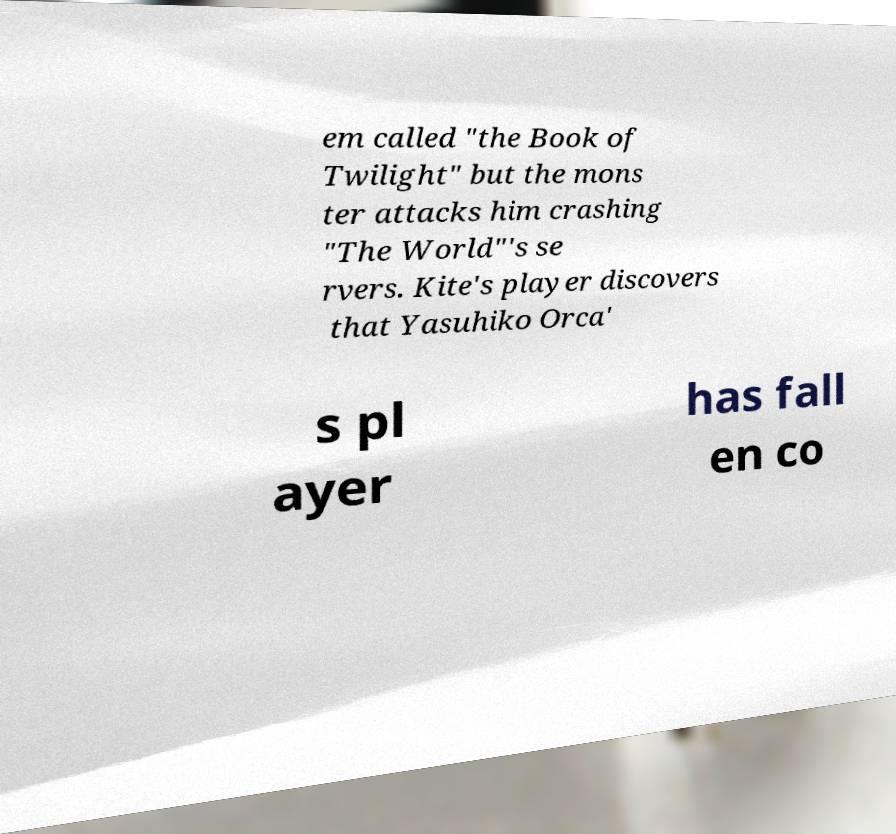Please identify and transcribe the text found in this image. em called "the Book of Twilight" but the mons ter attacks him crashing "The World"'s se rvers. Kite's player discovers that Yasuhiko Orca' s pl ayer has fall en co 